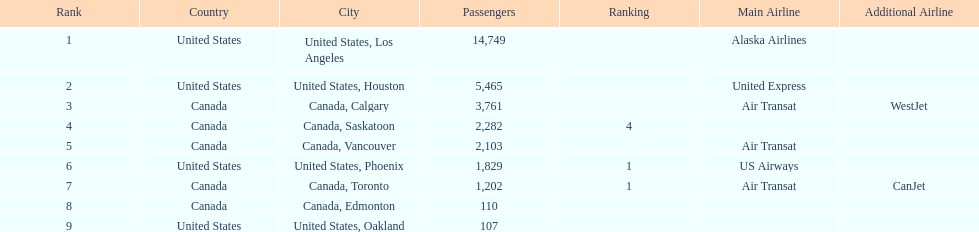Which cities had less than 2,000 passengers? United States, Phoenix, Canada, Toronto, Canada, Edmonton, United States, Oakland. Of these cities, which had fewer than 1,000 passengers? Canada, Edmonton, United States, Oakland. Of the cities in the previous answer, which one had only 107 passengers? United States, Oakland. 